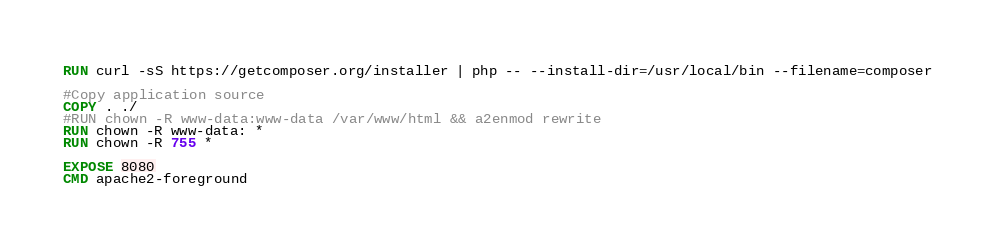<code> <loc_0><loc_0><loc_500><loc_500><_Dockerfile_>
RUN curl -sS https://getcomposer.org/installer | php -- --install-dir=/usr/local/bin --filename=composer

#Copy application source
COPY . ./
#RUN chown -R www-data:www-data /var/www/html && a2enmod rewrite
RUN chown -R www-data: *
RUN chown -R 755 *

EXPOSE 8080
CMD apache2-foreground
</code> 